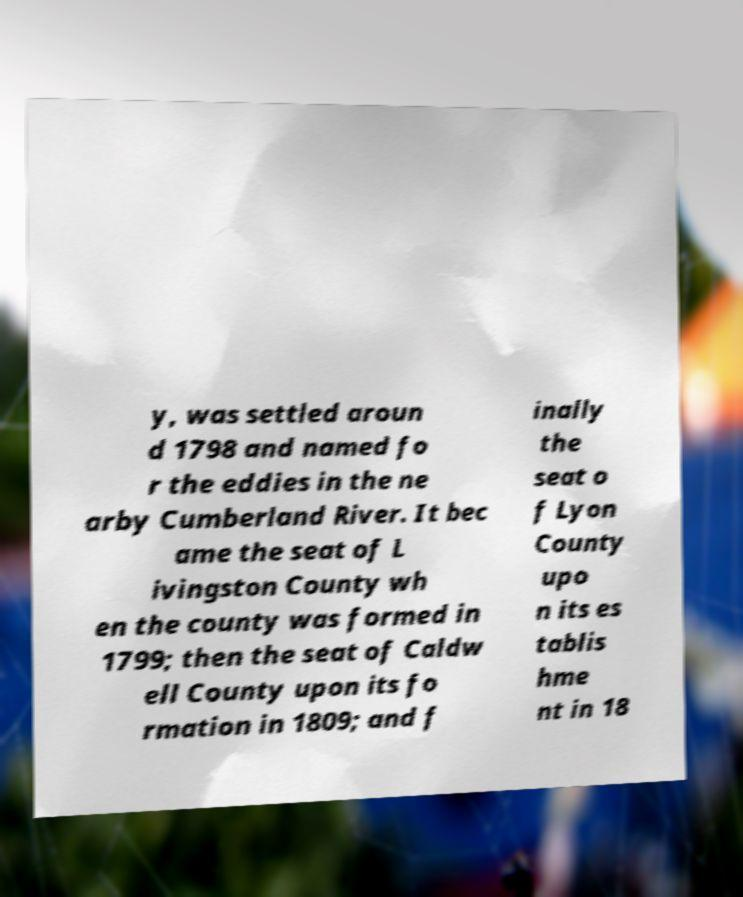Could you extract and type out the text from this image? y, was settled aroun d 1798 and named fo r the eddies in the ne arby Cumberland River. It bec ame the seat of L ivingston County wh en the county was formed in 1799; then the seat of Caldw ell County upon its fo rmation in 1809; and f inally the seat o f Lyon County upo n its es tablis hme nt in 18 